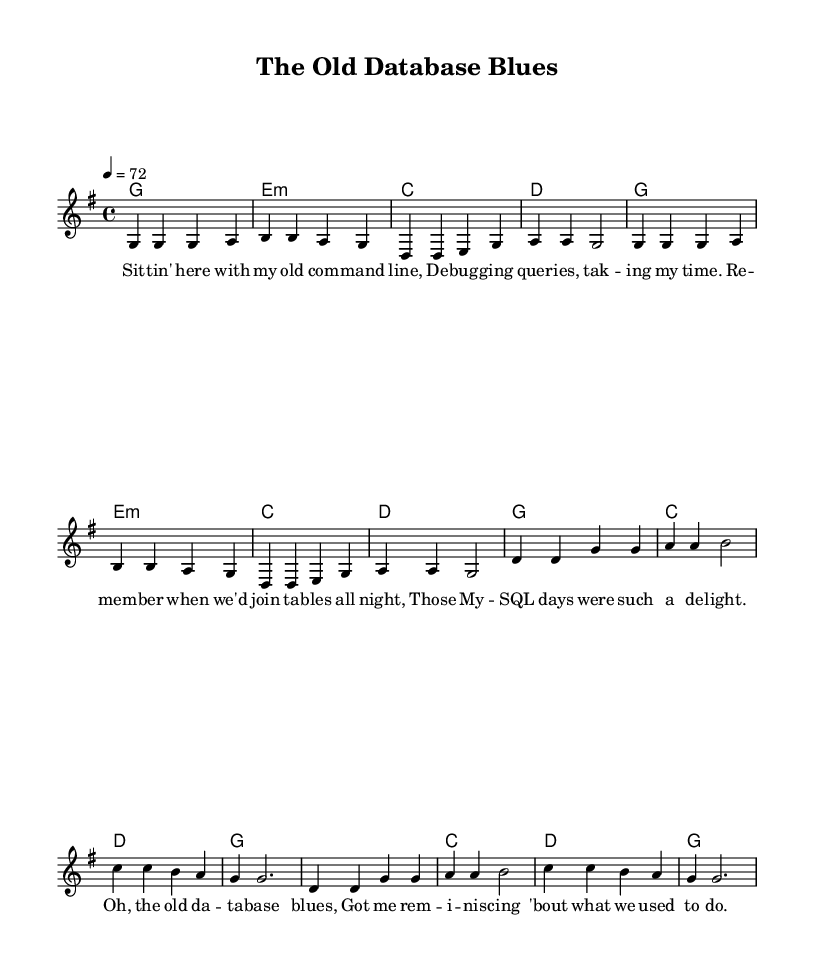What is the key signature of this music? The key signature is indicated at the beginning of the score. It shows one sharp, which means the key is G major.
Answer: G major What is the time signature of this music? The time signature is located at the beginning of the score, showing four beats per measure with a quarter note receiving one beat, indicated as 4/4.
Answer: 4/4 What is the tempo of this piece? The tempo marking is found in the global section, where it states that the tempo is set at 72 beats per minute, with each quarter note getting one beat.
Answer: 72 How many sections does this song have? By looking at the structure of the music, we can identify one verse and one chorus section, making a total of two distinct sections.
Answer: 2 What is the final chord of the chorus? The final chord of the chorus is specified in the chord progression and can be identified as the last chord in the chorus section, which is G major.
Answer: G What theme is primarily presented in the lyrics? The lyrics revolve around reminiscing about old computer systems and experiences related to debugging and using databases, forming a nostalgic theme that reflects on the past.
Answer: Nostalgia What type of musical verse is used in this ballad? The music has a regular verse-chorus structure, which is typical in country ballads, providing a narrative quality through its repeated segments.
Answer: Verse-chorus 